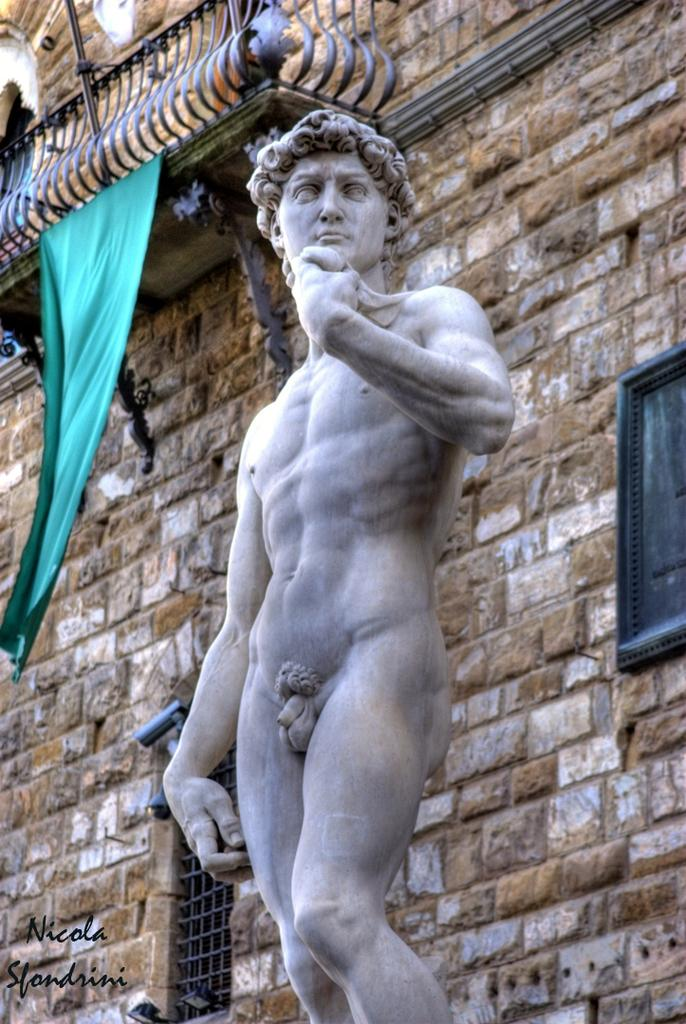What is the main subject of the image? There is a person's sculpture in the image. What type of structure is visible in the image? There is a building in the image. What architectural feature can be seen in the image? There is a balcony in the image. What can be seen through the windows in the image? The image was likely taken during the day, so the windows may show the outdoors or the interior of the building. What is the material of the cloth visible in the image? The facts do not specify the material of the cloth. What type of information is present in the image? There is text in the image. What type of apple is being used as a news source in the image? There is no apple or news source present in the image. What type of pleasure can be seen being derived from the sculpture in the image? The image does not depict any emotions or reactions to the sculpture, so it is not possible to determine if anyone is deriving pleasure from it. 